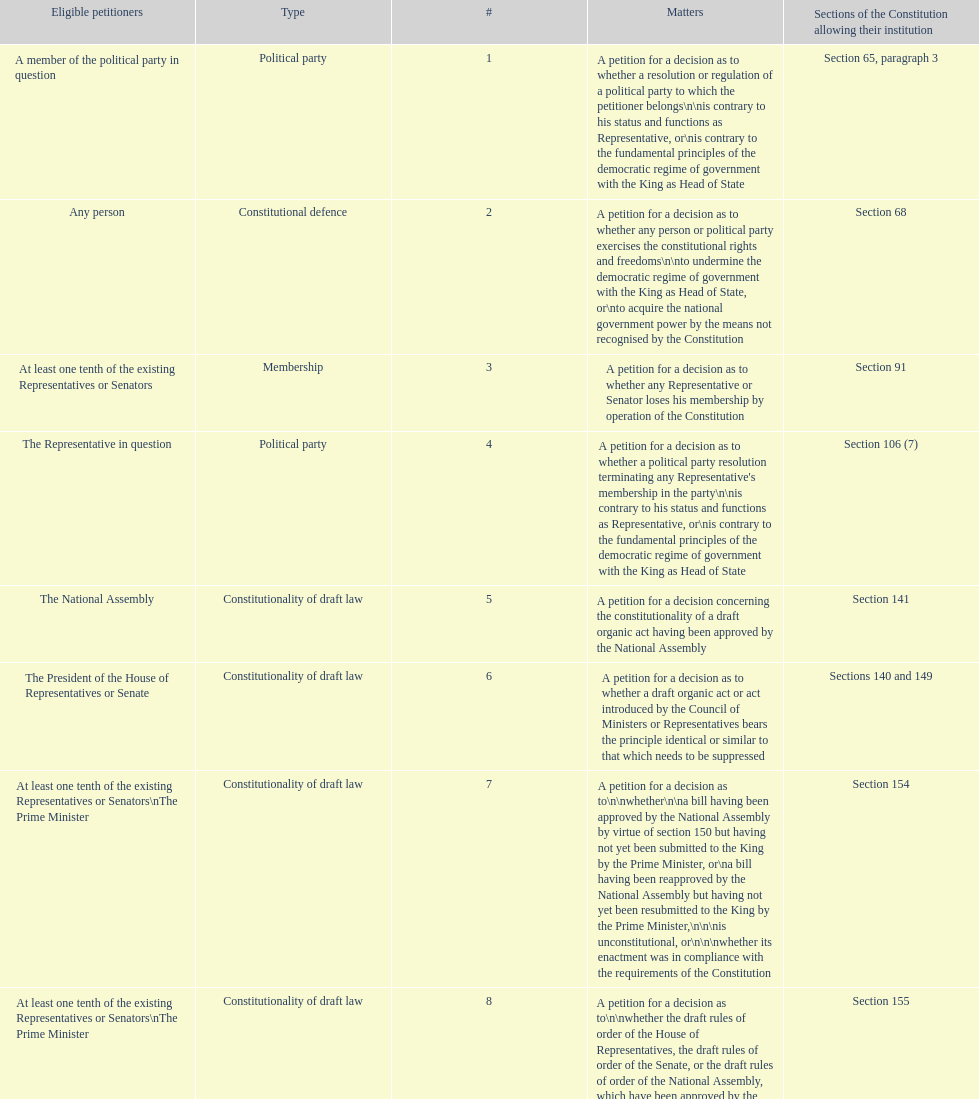Any person can petition matters 2 and 17. true or false? True. 